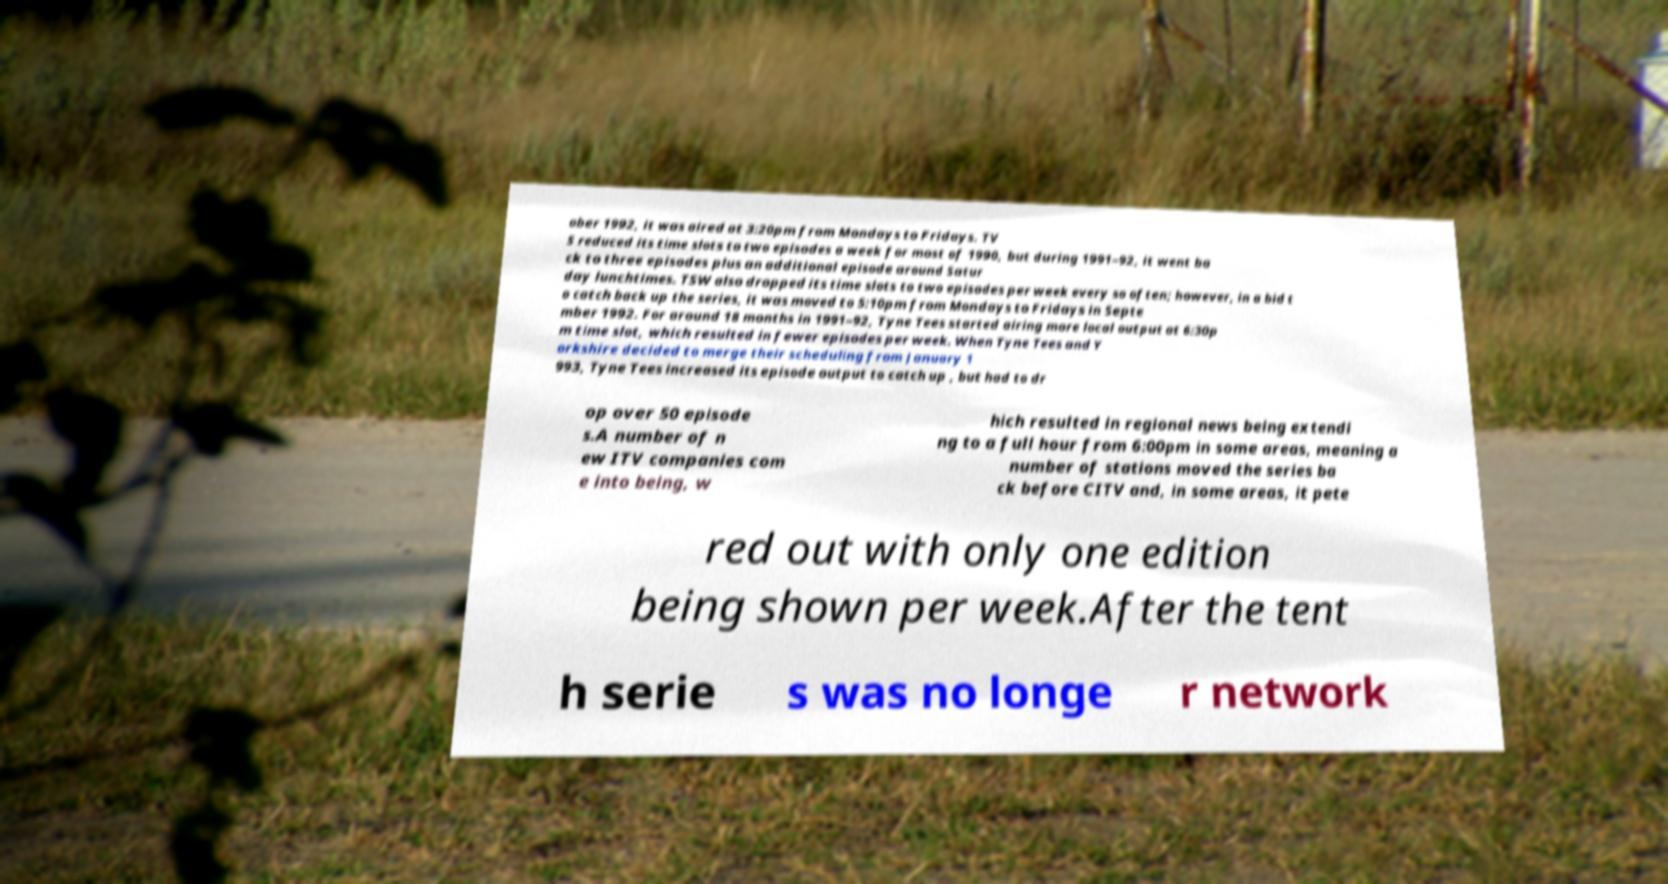There's text embedded in this image that I need extracted. Can you transcribe it verbatim? ober 1992, it was aired at 3:20pm from Mondays to Fridays. TV S reduced its time slots to two episodes a week for most of 1990, but during 1991–92, it went ba ck to three episodes plus an additional episode around Satur day lunchtimes. TSW also dropped its time slots to two episodes per week every so often; however, in a bid t o catch back up the series, it was moved to 5:10pm from Mondays to Fridays in Septe mber 1992. For around 18 months in 1991–92, Tyne Tees started airing more local output at 6:30p m time slot, which resulted in fewer episodes per week. When Tyne Tees and Y orkshire decided to merge their scheduling from January 1 993, Tyne Tees increased its episode output to catch up , but had to dr op over 50 episode s.A number of n ew ITV companies com e into being, w hich resulted in regional news being extendi ng to a full hour from 6:00pm in some areas, meaning a number of stations moved the series ba ck before CITV and, in some areas, it pete red out with only one edition being shown per week.After the tent h serie s was no longe r network 